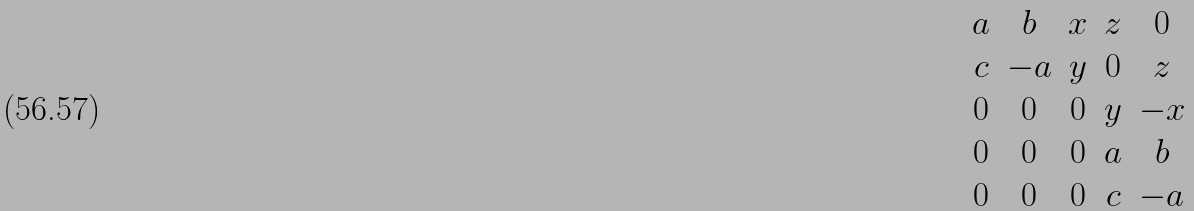<formula> <loc_0><loc_0><loc_500><loc_500>\begin{matrix} a & b & x & z & 0 \\ c & - a & y & 0 & z \\ 0 & 0 & 0 & y & - x \\ 0 & 0 & 0 & a & b \\ 0 & 0 & 0 & c & - a \end{matrix}</formula> 